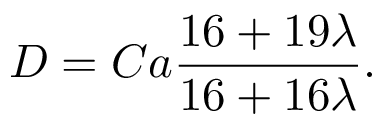<formula> <loc_0><loc_0><loc_500><loc_500>D = C a \frac { 1 6 + 1 9 \lambda } { 1 6 + 1 6 \lambda } .</formula> 